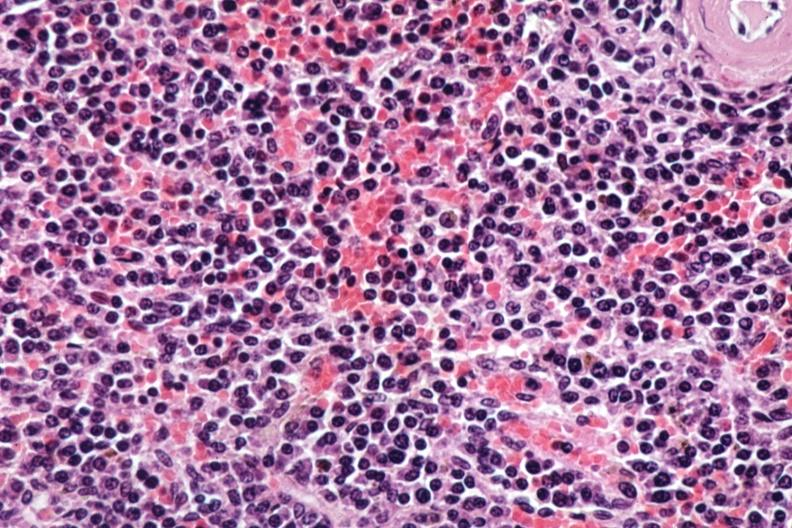what does this image show?
Answer the question using a single word or phrase. Sheets of atypical plasma cells 